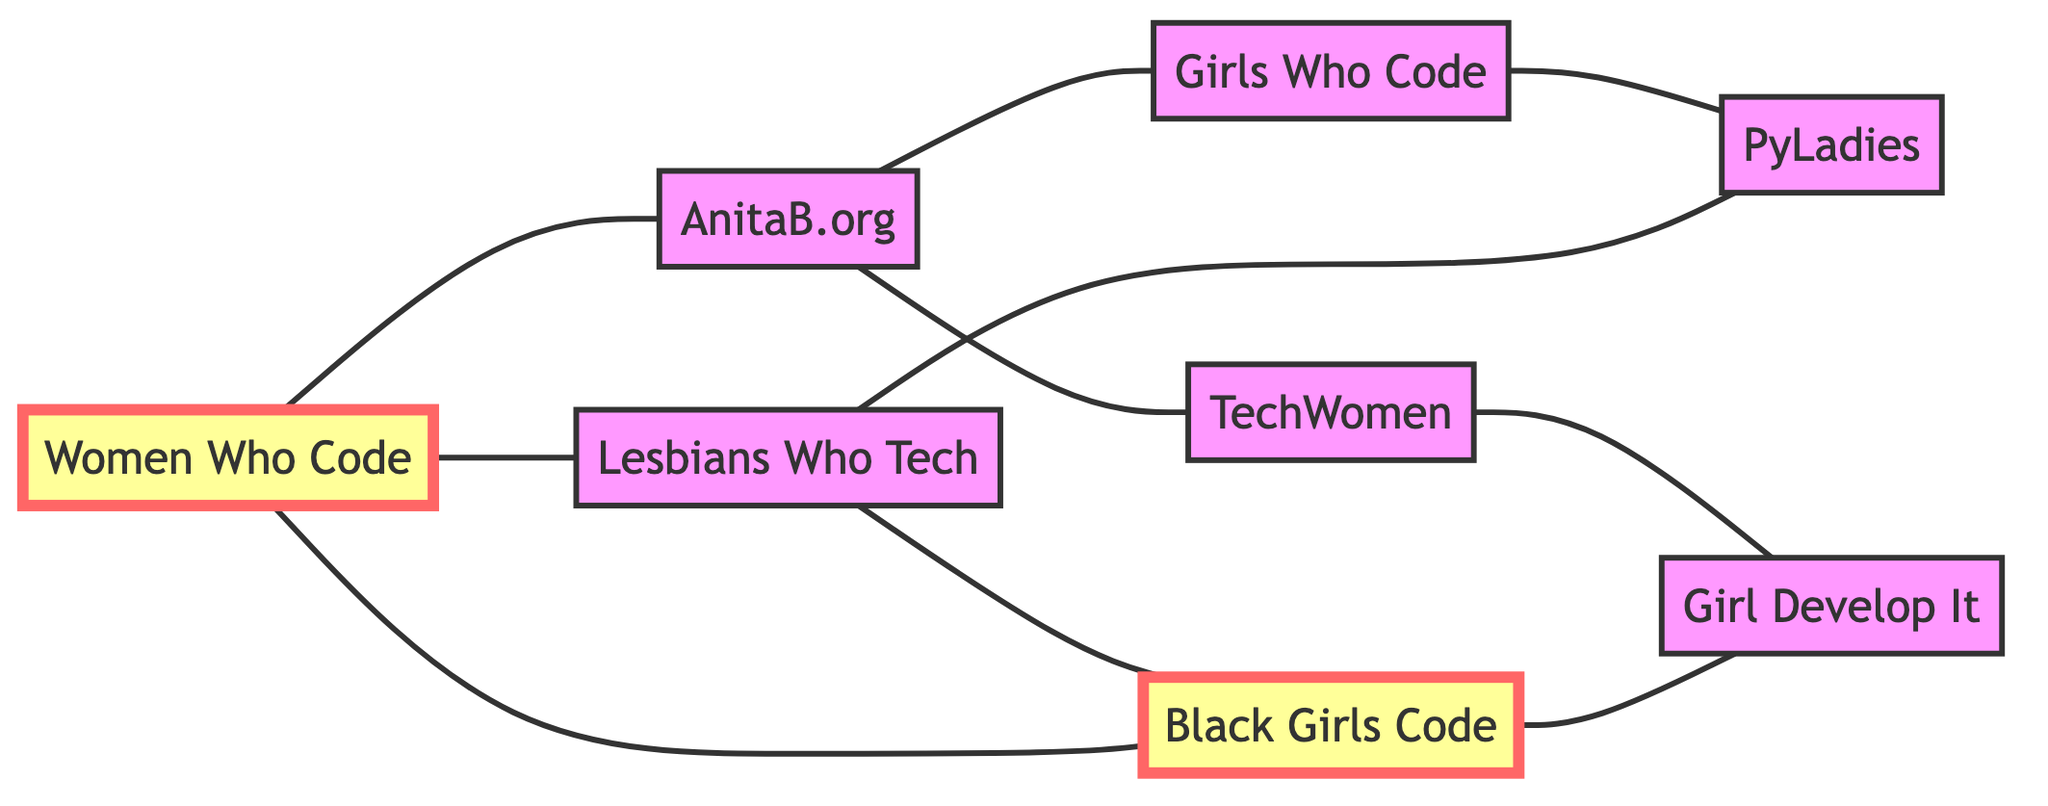What is the total number of nodes in the graph? The graph lists 8 different organizations, each represented as a unique node. By counting each entry in the nodes list, we confirm that there are 8 total nodes.
Answer: 8 Which two organizations are directly connected to "Women Who Code"? The edges indicate that "Women Who Code" is directly connected to "AnitaB.org", "Lesbians Who Tech", and "Black Girls Code". However, the question specifically asks for two organizations, so we can choose any two among them. Choosing "AnitaB.org" and "Lesbians Who Tech" works, as both are listed as connected.
Answer: AnitaB.org and Lesbians Who Tech How many edges are present in the graph? The graph lists several connections (edges) between the nodes. By counting the entries in the edges list, we find there are 10 distinct edges connecting these organizations.
Answer: 10 Which organization has the most connections? By examining the connections, we find that "Women Who Code" connects to three different organizations, while others connect to fewer. Thus, it holds the highest number of direct connections in the graph.
Answer: Women Who Code Is there a direct connection between "Girls Who Code" and "TechWomen"? The graph does not list a direct edge between "Girls Who Code" and "TechWomen", meaning there is no direct connection shown in the diagram.
Answer: No How many organizations are connected to "Lesbians Who Tech"? By checking the edges, "Lesbians Who Tech" connects to "Women Who Code", "Black Girls Code", and "PyLadies", totaling three connections.
Answer: 3 Are "Black Girls Code" and "Girl Develop It" directly connected? Upon reviewing the edges, we see there is no connection between "Black Girls Code" and "Girl Develop It". Therefore, they are not directly linked in the graph.
Answer: No Which two organizations are connected through "AnitaB.org"? The graph shows that "AnitaB.org" has direct edges connecting it to "Women Who Code" and "Girls Who Code". Thus, these two organizations are effectively linked through "AnitaB.org".
Answer: Women Who Code and Girls Who Code 